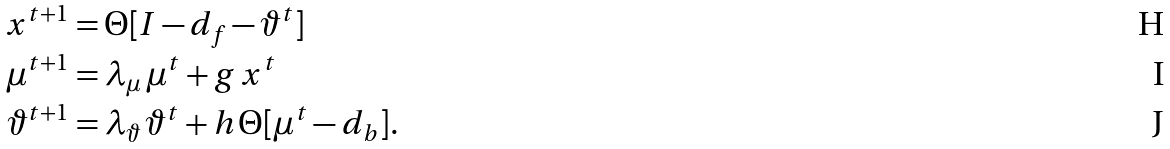<formula> <loc_0><loc_0><loc_500><loc_500>x ^ { t + 1 } & = \Theta [ I - d _ { f } - \vartheta ^ { t } ] \\ \mu ^ { t + 1 } & = \lambda _ { \mu } \, \mu ^ { t } + g \, x ^ { t } \\ \vartheta ^ { t + 1 } & = \lambda _ { \vartheta } \, \vartheta ^ { t } + h \, \Theta [ \mu ^ { t } - d _ { b } ] .</formula> 